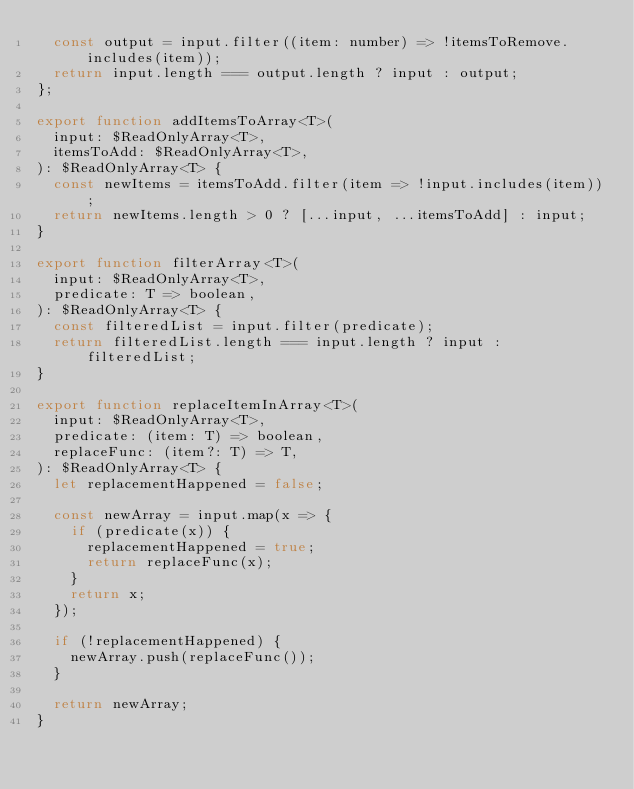Convert code to text. <code><loc_0><loc_0><loc_500><loc_500><_JavaScript_>  const output = input.filter((item: number) => !itemsToRemove.includes(item));
  return input.length === output.length ? input : output;
};

export function addItemsToArray<T>(
  input: $ReadOnlyArray<T>,
  itemsToAdd: $ReadOnlyArray<T>,
): $ReadOnlyArray<T> {
  const newItems = itemsToAdd.filter(item => !input.includes(item));
  return newItems.length > 0 ? [...input, ...itemsToAdd] : input;
}

export function filterArray<T>(
  input: $ReadOnlyArray<T>,
  predicate: T => boolean,
): $ReadOnlyArray<T> {
  const filteredList = input.filter(predicate);
  return filteredList.length === input.length ? input : filteredList;
}

export function replaceItemInArray<T>(
  input: $ReadOnlyArray<T>,
  predicate: (item: T) => boolean,
  replaceFunc: (item?: T) => T,
): $ReadOnlyArray<T> {
  let replacementHappened = false;

  const newArray = input.map(x => {
    if (predicate(x)) {
      replacementHappened = true;
      return replaceFunc(x);
    }
    return x;
  });

  if (!replacementHappened) {
    newArray.push(replaceFunc());
  }

  return newArray;
}
</code> 